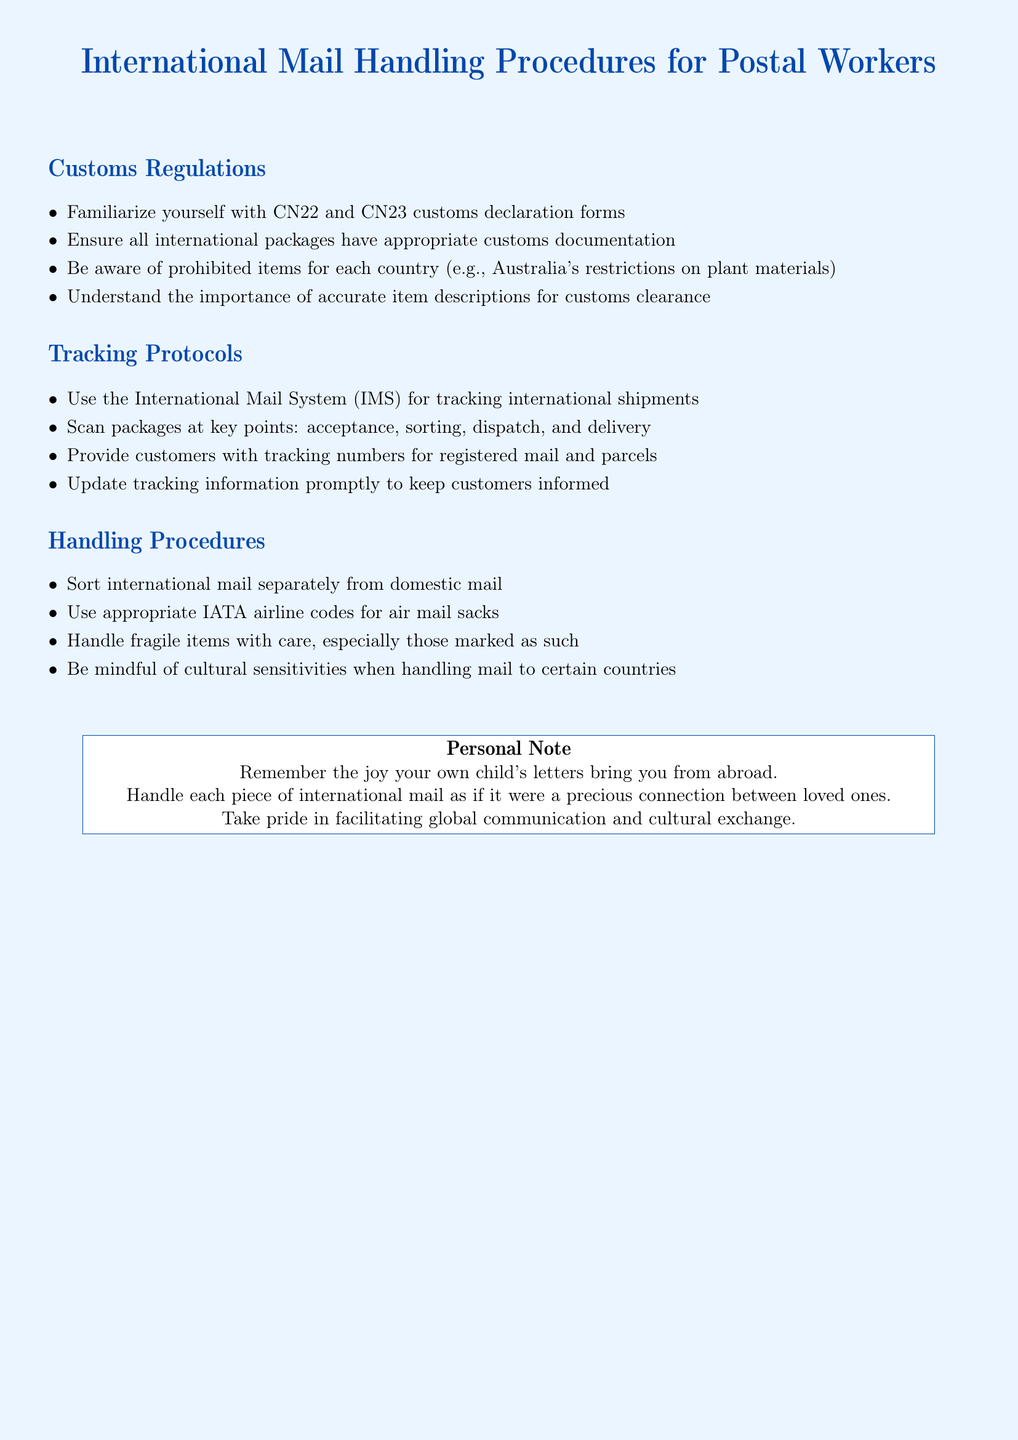What are CN22 and CN23? CN22 and CN23 are customs declaration forms that postal workers must familiarize themselves with.
Answer: customs declaration forms What should be used for tracking international shipments? The International Mail System (IMS) is specified for tracking international shipments.
Answer: International Mail System When should tracking information be updated? Tracking information should be updated promptly to keep customers informed.
Answer: promptly What is required when handling fragile items? Postal workers must handle fragile items with care, especially those marked as fragile.
Answer: with care Why is it important to understand item descriptions for customs clearance? Accurate item descriptions are crucial for customs clearance to avoid issues during shipping.
Answer: important for customs clearance What should international mail be sorted separately from? International mail should be sorted separately from domestic mail for appropriate handling.
Answer: domestic mail What is noted about cultural sensitivities? Postal workers should be mindful of cultural sensitivities when handling mail to certain countries.
Answer: cultural sensitivities What do postal workers provide customers for registered mail? They provide customers with tracking numbers for registered mail and parcels.
Answer: tracking numbers 